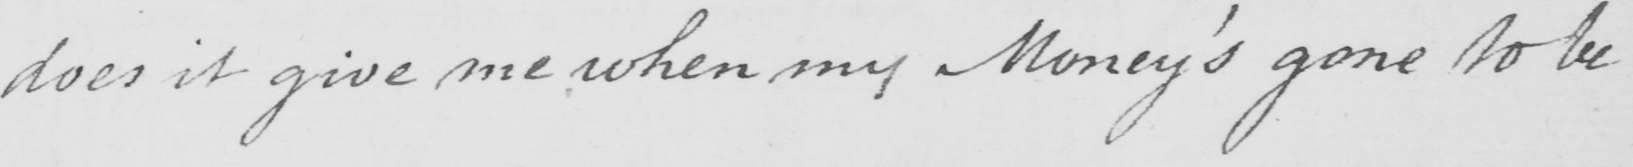Can you read and transcribe this handwriting? does it give me when my Money ' s gone to be 